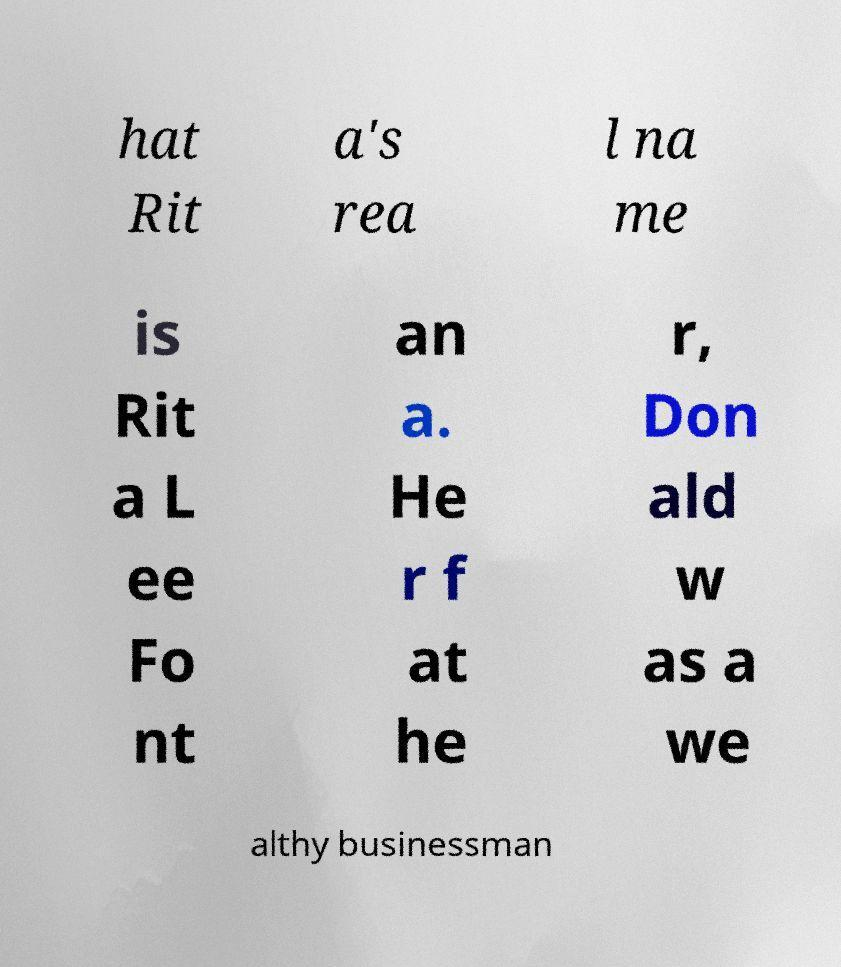Could you assist in decoding the text presented in this image and type it out clearly? hat Rit a's rea l na me is Rit a L ee Fo nt an a. He r f at he r, Don ald w as a we althy businessman 